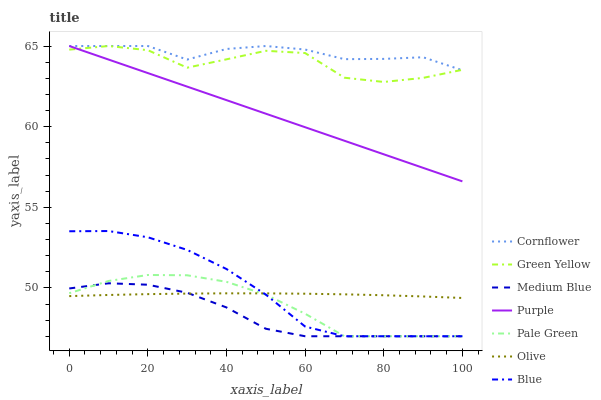Does Medium Blue have the minimum area under the curve?
Answer yes or no. Yes. Does Cornflower have the maximum area under the curve?
Answer yes or no. Yes. Does Purple have the minimum area under the curve?
Answer yes or no. No. Does Purple have the maximum area under the curve?
Answer yes or no. No. Is Purple the smoothest?
Answer yes or no. Yes. Is Green Yellow the roughest?
Answer yes or no. Yes. Is Cornflower the smoothest?
Answer yes or no. No. Is Cornflower the roughest?
Answer yes or no. No. Does Blue have the lowest value?
Answer yes or no. Yes. Does Purple have the lowest value?
Answer yes or no. No. Does Green Yellow have the highest value?
Answer yes or no. Yes. Does Medium Blue have the highest value?
Answer yes or no. No. Is Pale Green less than Purple?
Answer yes or no. Yes. Is Green Yellow greater than Pale Green?
Answer yes or no. Yes. Does Medium Blue intersect Pale Green?
Answer yes or no. Yes. Is Medium Blue less than Pale Green?
Answer yes or no. No. Is Medium Blue greater than Pale Green?
Answer yes or no. No. Does Pale Green intersect Purple?
Answer yes or no. No. 